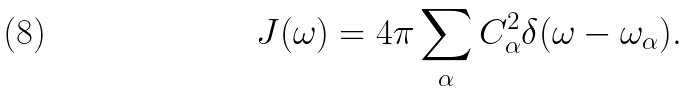Convert formula to latex. <formula><loc_0><loc_0><loc_500><loc_500>J ( \omega ) = 4 \pi \sum _ { \alpha } C _ { \alpha } ^ { 2 } \delta ( \omega - \omega _ { \alpha } ) .</formula> 